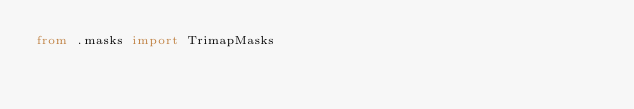<code> <loc_0><loc_0><loc_500><loc_500><_Python_>from .masks import TrimapMasks
</code> 